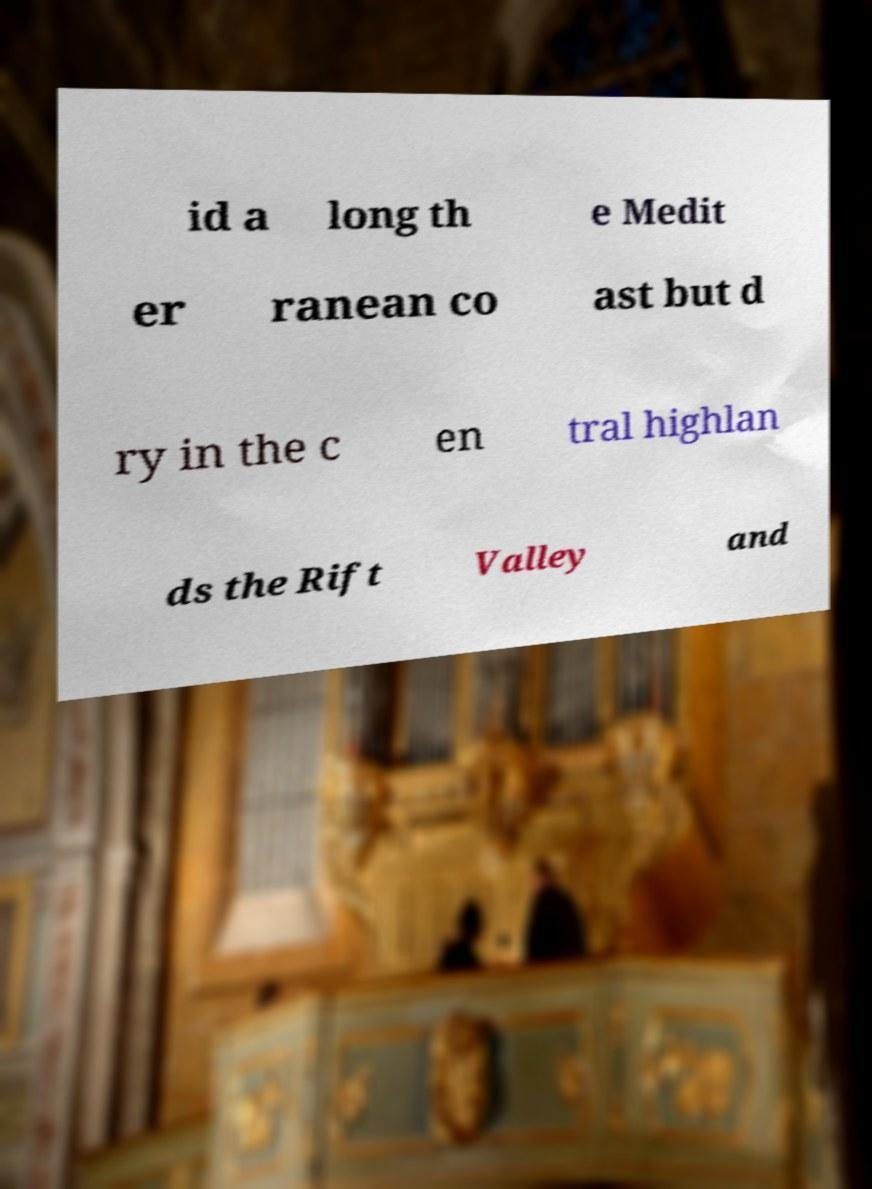Could you assist in decoding the text presented in this image and type it out clearly? id a long th e Medit er ranean co ast but d ry in the c en tral highlan ds the Rift Valley and 